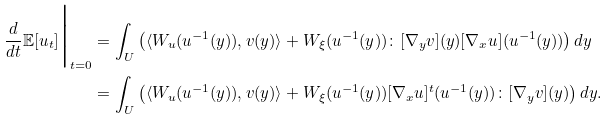<formula> <loc_0><loc_0><loc_500><loc_500>\frac { d } { d t } \mathbb { E } [ u _ { t } ] \Big | _ { t = 0 } & = \int _ { U } \left ( \langle W _ { u } ( u ^ { - 1 } ( y ) ) , v ( y ) \rangle + W _ { \xi } ( u ^ { - 1 } ( y ) ) \colon [ \nabla _ { y } v ] ( y ) [ \nabla _ { x } u ] ( u ^ { - 1 } ( y ) ) \right ) d y \\ & = \int _ { U } \left ( \langle W _ { u } ( u ^ { - 1 } ( y ) ) , v ( y ) \rangle + W _ { \xi } ( u ^ { - 1 } ( y ) ) [ \nabla _ { x } u ] ^ { t } ( u ^ { - 1 } ( y ) ) \colon [ \nabla _ { y } v ] ( y ) \right ) d y .</formula> 